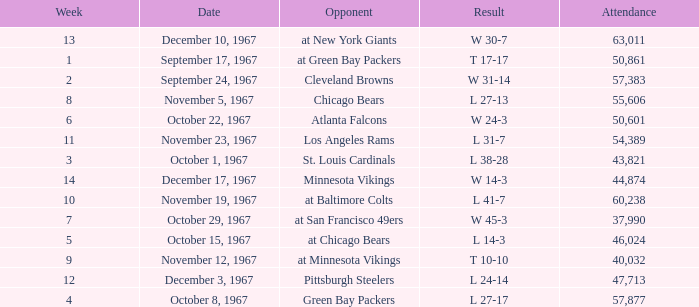Which Result has an Opponent of minnesota vikings? W 14-3. 